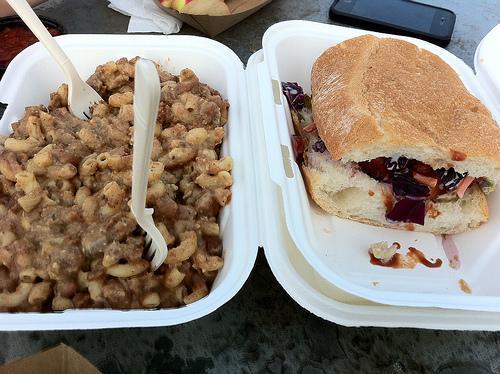How many forks are there?
Give a very brief answer. 2. 